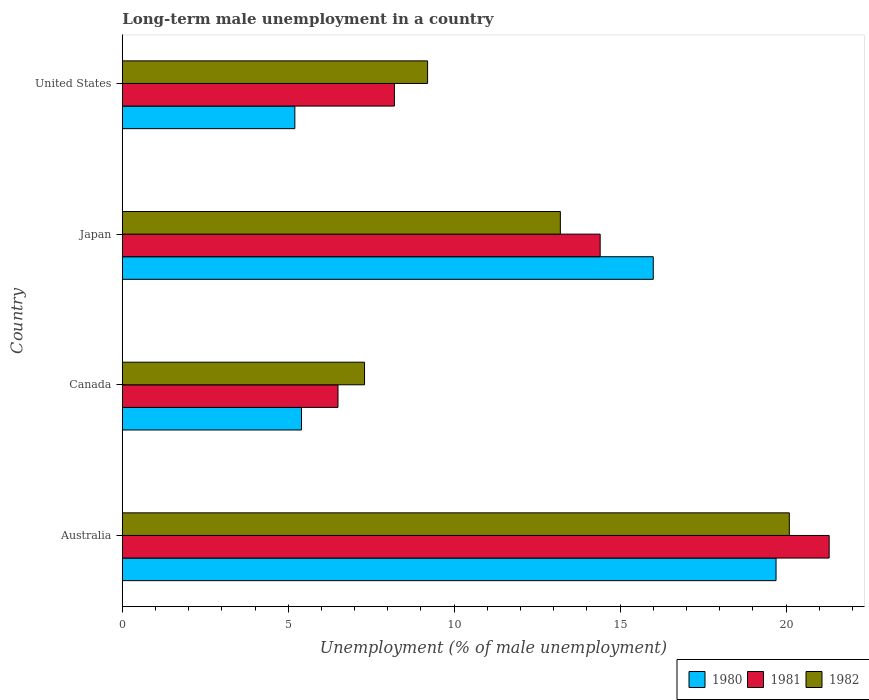How many groups of bars are there?
Your answer should be very brief. 4. Are the number of bars per tick equal to the number of legend labels?
Your answer should be very brief. Yes. How many bars are there on the 2nd tick from the bottom?
Give a very brief answer. 3. What is the label of the 4th group of bars from the top?
Ensure brevity in your answer.  Australia. What is the percentage of long-term unemployed male population in 1980 in Canada?
Make the answer very short. 5.4. Across all countries, what is the maximum percentage of long-term unemployed male population in 1980?
Ensure brevity in your answer.  19.7. Across all countries, what is the minimum percentage of long-term unemployed male population in 1981?
Provide a short and direct response. 6.5. In which country was the percentage of long-term unemployed male population in 1982 minimum?
Keep it short and to the point. Canada. What is the total percentage of long-term unemployed male population in 1982 in the graph?
Your answer should be very brief. 49.8. What is the difference between the percentage of long-term unemployed male population in 1982 in Japan and that in United States?
Your response must be concise. 4. What is the difference between the percentage of long-term unemployed male population in 1982 in Japan and the percentage of long-term unemployed male population in 1981 in Canada?
Your answer should be compact. 6.7. What is the average percentage of long-term unemployed male population in 1982 per country?
Offer a terse response. 12.45. What is the difference between the percentage of long-term unemployed male population in 1982 and percentage of long-term unemployed male population in 1981 in Australia?
Your answer should be compact. -1.2. In how many countries, is the percentage of long-term unemployed male population in 1980 greater than 13 %?
Your answer should be compact. 2. What is the ratio of the percentage of long-term unemployed male population in 1981 in Japan to that in United States?
Your response must be concise. 1.76. Is the percentage of long-term unemployed male population in 1980 in Japan less than that in United States?
Your answer should be compact. No. Is the difference between the percentage of long-term unemployed male population in 1982 in Australia and Canada greater than the difference between the percentage of long-term unemployed male population in 1981 in Australia and Canada?
Make the answer very short. No. What is the difference between the highest and the second highest percentage of long-term unemployed male population in 1980?
Your answer should be compact. 3.7. What is the difference between the highest and the lowest percentage of long-term unemployed male population in 1981?
Ensure brevity in your answer.  14.8. In how many countries, is the percentage of long-term unemployed male population in 1980 greater than the average percentage of long-term unemployed male population in 1980 taken over all countries?
Your answer should be very brief. 2. Is the sum of the percentage of long-term unemployed male population in 1981 in Japan and United States greater than the maximum percentage of long-term unemployed male population in 1982 across all countries?
Ensure brevity in your answer.  Yes. Is it the case that in every country, the sum of the percentage of long-term unemployed male population in 1981 and percentage of long-term unemployed male population in 1982 is greater than the percentage of long-term unemployed male population in 1980?
Offer a very short reply. Yes. How many countries are there in the graph?
Your response must be concise. 4. What is the difference between two consecutive major ticks on the X-axis?
Offer a terse response. 5. Does the graph contain any zero values?
Keep it short and to the point. No. How are the legend labels stacked?
Provide a succinct answer. Horizontal. What is the title of the graph?
Your answer should be compact. Long-term male unemployment in a country. What is the label or title of the X-axis?
Your response must be concise. Unemployment (% of male unemployment). What is the label or title of the Y-axis?
Your response must be concise. Country. What is the Unemployment (% of male unemployment) of 1980 in Australia?
Provide a succinct answer. 19.7. What is the Unemployment (% of male unemployment) of 1981 in Australia?
Provide a succinct answer. 21.3. What is the Unemployment (% of male unemployment) in 1982 in Australia?
Offer a terse response. 20.1. What is the Unemployment (% of male unemployment) in 1980 in Canada?
Make the answer very short. 5.4. What is the Unemployment (% of male unemployment) of 1982 in Canada?
Ensure brevity in your answer.  7.3. What is the Unemployment (% of male unemployment) of 1981 in Japan?
Offer a very short reply. 14.4. What is the Unemployment (% of male unemployment) of 1982 in Japan?
Keep it short and to the point. 13.2. What is the Unemployment (% of male unemployment) in 1980 in United States?
Give a very brief answer. 5.2. What is the Unemployment (% of male unemployment) in 1981 in United States?
Provide a succinct answer. 8.2. What is the Unemployment (% of male unemployment) in 1982 in United States?
Give a very brief answer. 9.2. Across all countries, what is the maximum Unemployment (% of male unemployment) of 1980?
Give a very brief answer. 19.7. Across all countries, what is the maximum Unemployment (% of male unemployment) in 1981?
Provide a short and direct response. 21.3. Across all countries, what is the maximum Unemployment (% of male unemployment) in 1982?
Your answer should be compact. 20.1. Across all countries, what is the minimum Unemployment (% of male unemployment) in 1980?
Your response must be concise. 5.2. Across all countries, what is the minimum Unemployment (% of male unemployment) in 1981?
Make the answer very short. 6.5. Across all countries, what is the minimum Unemployment (% of male unemployment) of 1982?
Make the answer very short. 7.3. What is the total Unemployment (% of male unemployment) of 1980 in the graph?
Your answer should be very brief. 46.3. What is the total Unemployment (% of male unemployment) in 1981 in the graph?
Give a very brief answer. 50.4. What is the total Unemployment (% of male unemployment) in 1982 in the graph?
Your response must be concise. 49.8. What is the difference between the Unemployment (% of male unemployment) of 1980 in Australia and that in United States?
Give a very brief answer. 14.5. What is the difference between the Unemployment (% of male unemployment) in 1981 in Australia and that in United States?
Offer a very short reply. 13.1. What is the difference between the Unemployment (% of male unemployment) of 1982 in Australia and that in United States?
Keep it short and to the point. 10.9. What is the difference between the Unemployment (% of male unemployment) of 1980 in Canada and that in Japan?
Offer a very short reply. -10.6. What is the difference between the Unemployment (% of male unemployment) in 1982 in Canada and that in Japan?
Your answer should be very brief. -5.9. What is the difference between the Unemployment (% of male unemployment) in 1980 in Canada and that in United States?
Offer a very short reply. 0.2. What is the difference between the Unemployment (% of male unemployment) of 1981 in Canada and that in United States?
Give a very brief answer. -1.7. What is the difference between the Unemployment (% of male unemployment) in 1980 in Japan and that in United States?
Provide a short and direct response. 10.8. What is the difference between the Unemployment (% of male unemployment) of 1981 in Japan and that in United States?
Ensure brevity in your answer.  6.2. What is the difference between the Unemployment (% of male unemployment) of 1982 in Japan and that in United States?
Ensure brevity in your answer.  4. What is the difference between the Unemployment (% of male unemployment) in 1980 in Australia and the Unemployment (% of male unemployment) in 1981 in Canada?
Your answer should be compact. 13.2. What is the difference between the Unemployment (% of male unemployment) in 1980 in Australia and the Unemployment (% of male unemployment) in 1982 in Japan?
Provide a short and direct response. 6.5. What is the difference between the Unemployment (% of male unemployment) of 1980 in Australia and the Unemployment (% of male unemployment) of 1982 in United States?
Ensure brevity in your answer.  10.5. What is the difference between the Unemployment (% of male unemployment) in 1981 in Australia and the Unemployment (% of male unemployment) in 1982 in United States?
Give a very brief answer. 12.1. What is the difference between the Unemployment (% of male unemployment) in 1980 in Canada and the Unemployment (% of male unemployment) in 1982 in Japan?
Keep it short and to the point. -7.8. What is the average Unemployment (% of male unemployment) in 1980 per country?
Provide a short and direct response. 11.57. What is the average Unemployment (% of male unemployment) of 1981 per country?
Offer a terse response. 12.6. What is the average Unemployment (% of male unemployment) in 1982 per country?
Keep it short and to the point. 12.45. What is the difference between the Unemployment (% of male unemployment) in 1980 and Unemployment (% of male unemployment) in 1982 in Canada?
Keep it short and to the point. -1.9. What is the difference between the Unemployment (% of male unemployment) in 1980 and Unemployment (% of male unemployment) in 1982 in Japan?
Provide a short and direct response. 2.8. What is the difference between the Unemployment (% of male unemployment) of 1980 and Unemployment (% of male unemployment) of 1981 in United States?
Offer a very short reply. -3. What is the difference between the Unemployment (% of male unemployment) of 1981 and Unemployment (% of male unemployment) of 1982 in United States?
Give a very brief answer. -1. What is the ratio of the Unemployment (% of male unemployment) of 1980 in Australia to that in Canada?
Ensure brevity in your answer.  3.65. What is the ratio of the Unemployment (% of male unemployment) of 1981 in Australia to that in Canada?
Your response must be concise. 3.28. What is the ratio of the Unemployment (% of male unemployment) of 1982 in Australia to that in Canada?
Provide a succinct answer. 2.75. What is the ratio of the Unemployment (% of male unemployment) in 1980 in Australia to that in Japan?
Provide a short and direct response. 1.23. What is the ratio of the Unemployment (% of male unemployment) in 1981 in Australia to that in Japan?
Your answer should be very brief. 1.48. What is the ratio of the Unemployment (% of male unemployment) of 1982 in Australia to that in Japan?
Provide a succinct answer. 1.52. What is the ratio of the Unemployment (% of male unemployment) in 1980 in Australia to that in United States?
Give a very brief answer. 3.79. What is the ratio of the Unemployment (% of male unemployment) in 1981 in Australia to that in United States?
Make the answer very short. 2.6. What is the ratio of the Unemployment (% of male unemployment) of 1982 in Australia to that in United States?
Give a very brief answer. 2.18. What is the ratio of the Unemployment (% of male unemployment) in 1980 in Canada to that in Japan?
Make the answer very short. 0.34. What is the ratio of the Unemployment (% of male unemployment) of 1981 in Canada to that in Japan?
Provide a short and direct response. 0.45. What is the ratio of the Unemployment (% of male unemployment) in 1982 in Canada to that in Japan?
Give a very brief answer. 0.55. What is the ratio of the Unemployment (% of male unemployment) of 1980 in Canada to that in United States?
Provide a short and direct response. 1.04. What is the ratio of the Unemployment (% of male unemployment) of 1981 in Canada to that in United States?
Provide a succinct answer. 0.79. What is the ratio of the Unemployment (% of male unemployment) of 1982 in Canada to that in United States?
Give a very brief answer. 0.79. What is the ratio of the Unemployment (% of male unemployment) in 1980 in Japan to that in United States?
Offer a very short reply. 3.08. What is the ratio of the Unemployment (% of male unemployment) of 1981 in Japan to that in United States?
Offer a very short reply. 1.76. What is the ratio of the Unemployment (% of male unemployment) in 1982 in Japan to that in United States?
Offer a terse response. 1.43. What is the difference between the highest and the second highest Unemployment (% of male unemployment) in 1980?
Give a very brief answer. 3.7. What is the difference between the highest and the second highest Unemployment (% of male unemployment) in 1981?
Give a very brief answer. 6.9. What is the difference between the highest and the second highest Unemployment (% of male unemployment) in 1982?
Provide a succinct answer. 6.9. What is the difference between the highest and the lowest Unemployment (% of male unemployment) in 1980?
Provide a short and direct response. 14.5. What is the difference between the highest and the lowest Unemployment (% of male unemployment) of 1981?
Keep it short and to the point. 14.8. What is the difference between the highest and the lowest Unemployment (% of male unemployment) in 1982?
Your response must be concise. 12.8. 